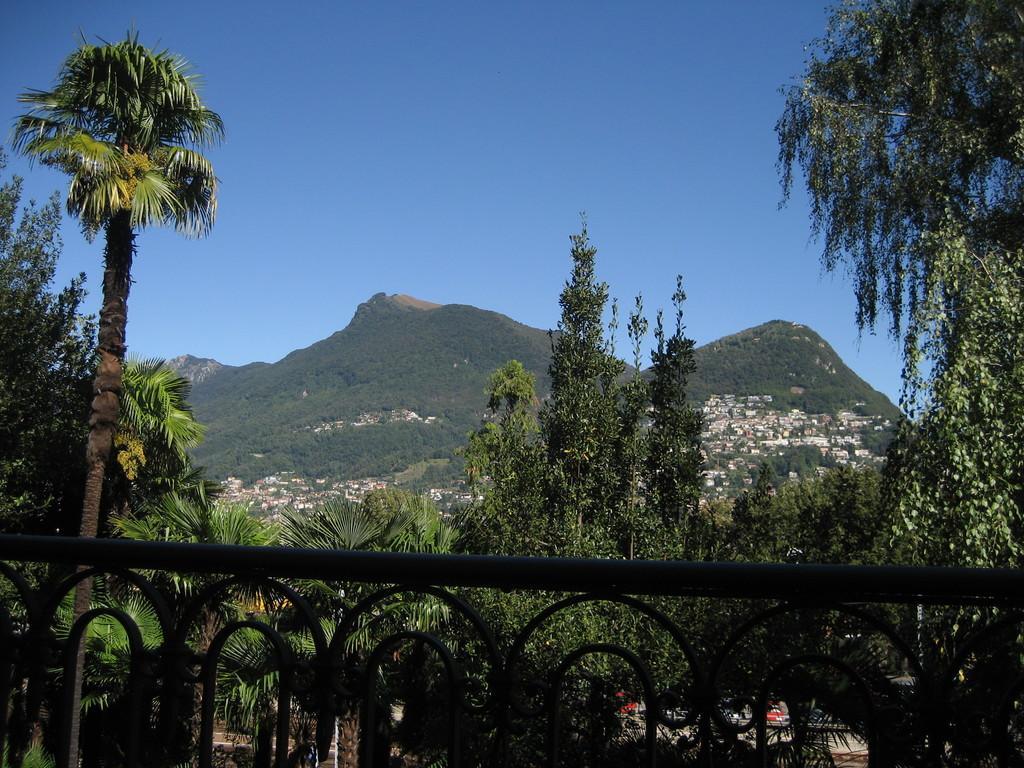How would you summarize this image in a sentence or two? In this picture we can see few metal rods and trees, in the background we can find few houses and hills. 